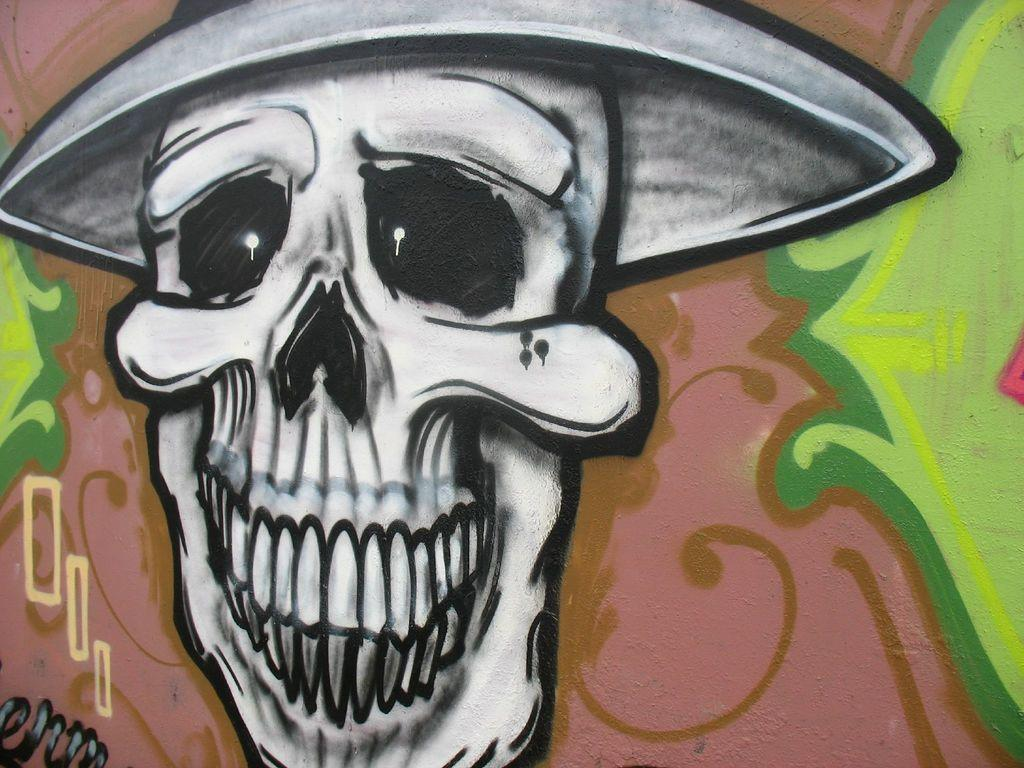What is the main subject of the painting in the image? The painting depicts a skull. Are there any other elements in the painting besides the skull? Yes, the painting includes other designs. Where is the painting located in the image? The painting is on a wall. What type of shoes can be seen on the giraffe in the image? There is no giraffe or shoes present in the image; the painting only depicts a skull and other designs. 